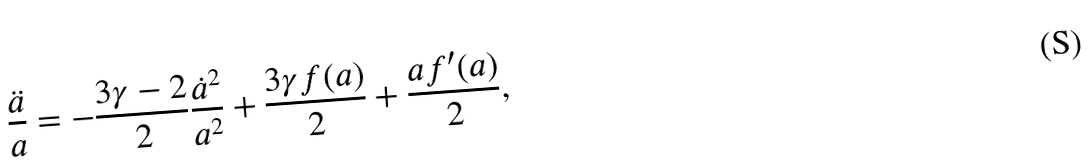Convert formula to latex. <formula><loc_0><loc_0><loc_500><loc_500>\frac { \ddot { a } } { a } = - \frac { 3 \gamma - 2 } { 2 } \frac { \dot { a } ^ { 2 } } { a ^ { 2 } } + \frac { 3 \gamma f ( a ) } { 2 } + \frac { a f ^ { \prime } ( a ) } { 2 } ,</formula> 